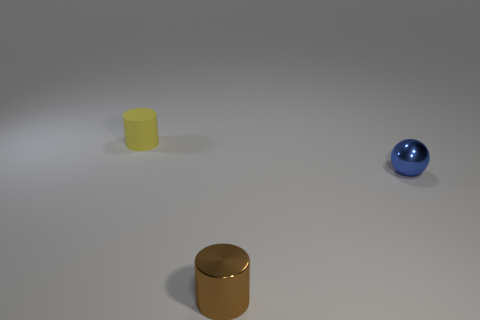Add 1 small cylinders. How many objects exist? 4 Subtract all balls. How many objects are left? 2 Subtract all small brown cylinders. Subtract all things. How many objects are left? 1 Add 3 yellow matte cylinders. How many yellow matte cylinders are left? 4 Add 2 small blue objects. How many small blue objects exist? 3 Subtract 0 blue cylinders. How many objects are left? 3 